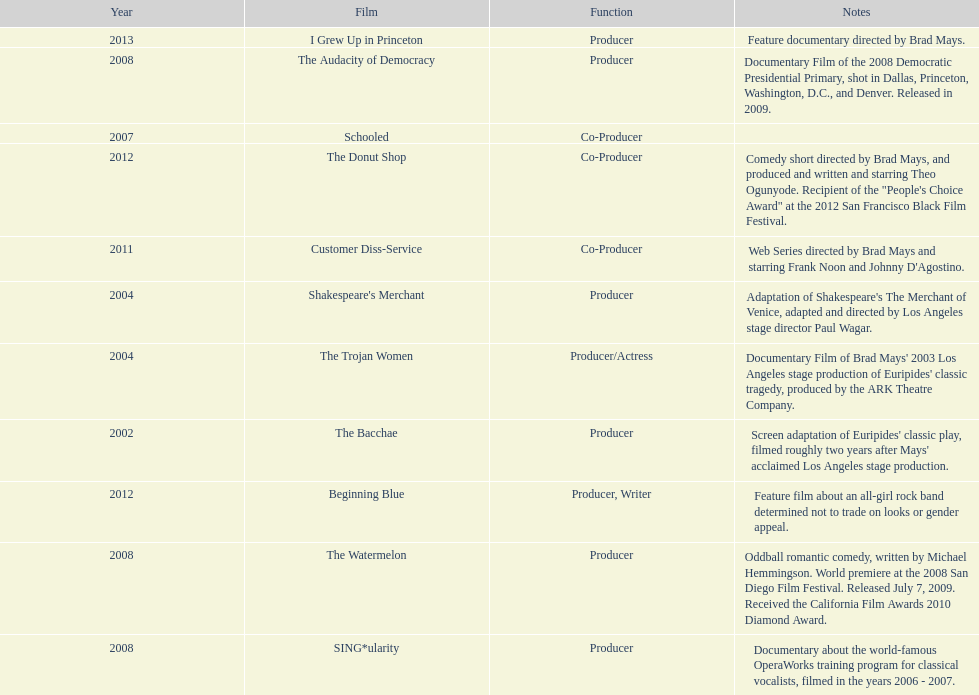Which year was there at least three movies? 2008. 